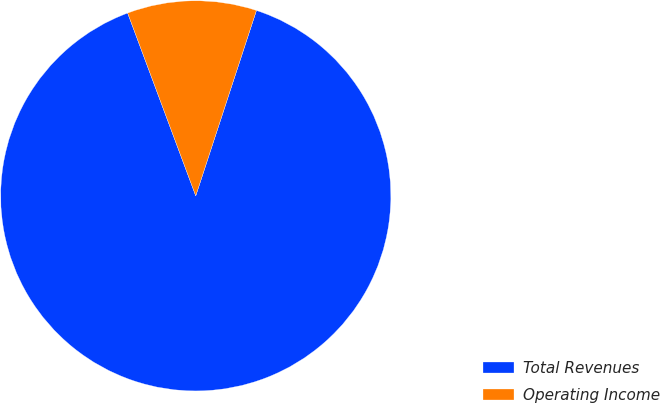<chart> <loc_0><loc_0><loc_500><loc_500><pie_chart><fcel>Total Revenues<fcel>Operating Income<nl><fcel>89.29%<fcel>10.71%<nl></chart> 